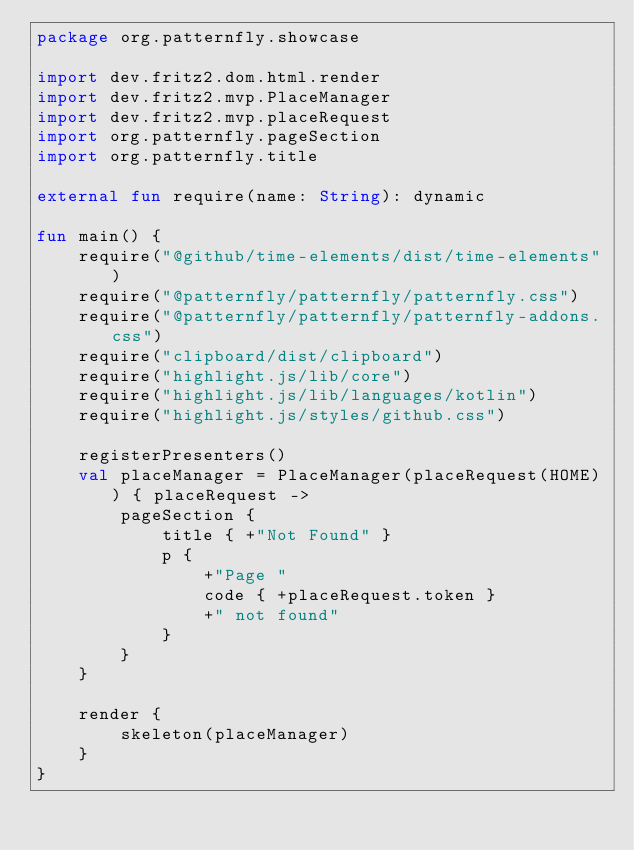Convert code to text. <code><loc_0><loc_0><loc_500><loc_500><_Kotlin_>package org.patternfly.showcase

import dev.fritz2.dom.html.render
import dev.fritz2.mvp.PlaceManager
import dev.fritz2.mvp.placeRequest
import org.patternfly.pageSection
import org.patternfly.title

external fun require(name: String): dynamic

fun main() {
    require("@github/time-elements/dist/time-elements")
    require("@patternfly/patternfly/patternfly.css")
    require("@patternfly/patternfly/patternfly-addons.css")
    require("clipboard/dist/clipboard")
    require("highlight.js/lib/core")
    require("highlight.js/lib/languages/kotlin")
    require("highlight.js/styles/github.css")

    registerPresenters()
    val placeManager = PlaceManager(placeRequest(HOME)) { placeRequest ->
        pageSection {
            title { +"Not Found" }
            p {
                +"Page "
                code { +placeRequest.token }
                +" not found"
            }
        }
    }

    render {
        skeleton(placeManager)
    }
}
</code> 